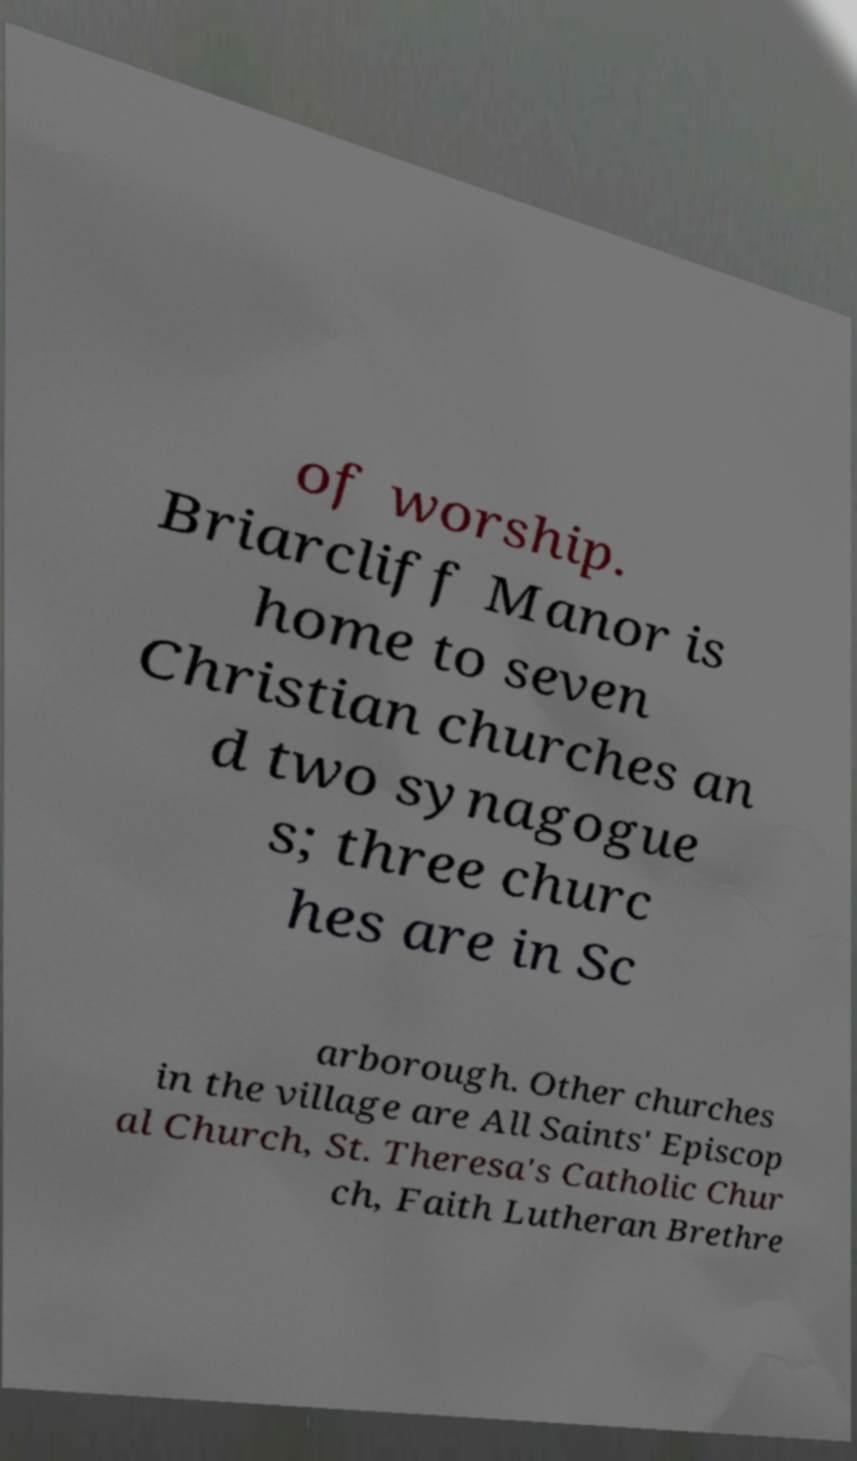Can you read and provide the text displayed in the image?This photo seems to have some interesting text. Can you extract and type it out for me? of worship. Briarcliff Manor is home to seven Christian churches an d two synagogue s; three churc hes are in Sc arborough. Other churches in the village are All Saints' Episcop al Church, St. Theresa's Catholic Chur ch, Faith Lutheran Brethre 